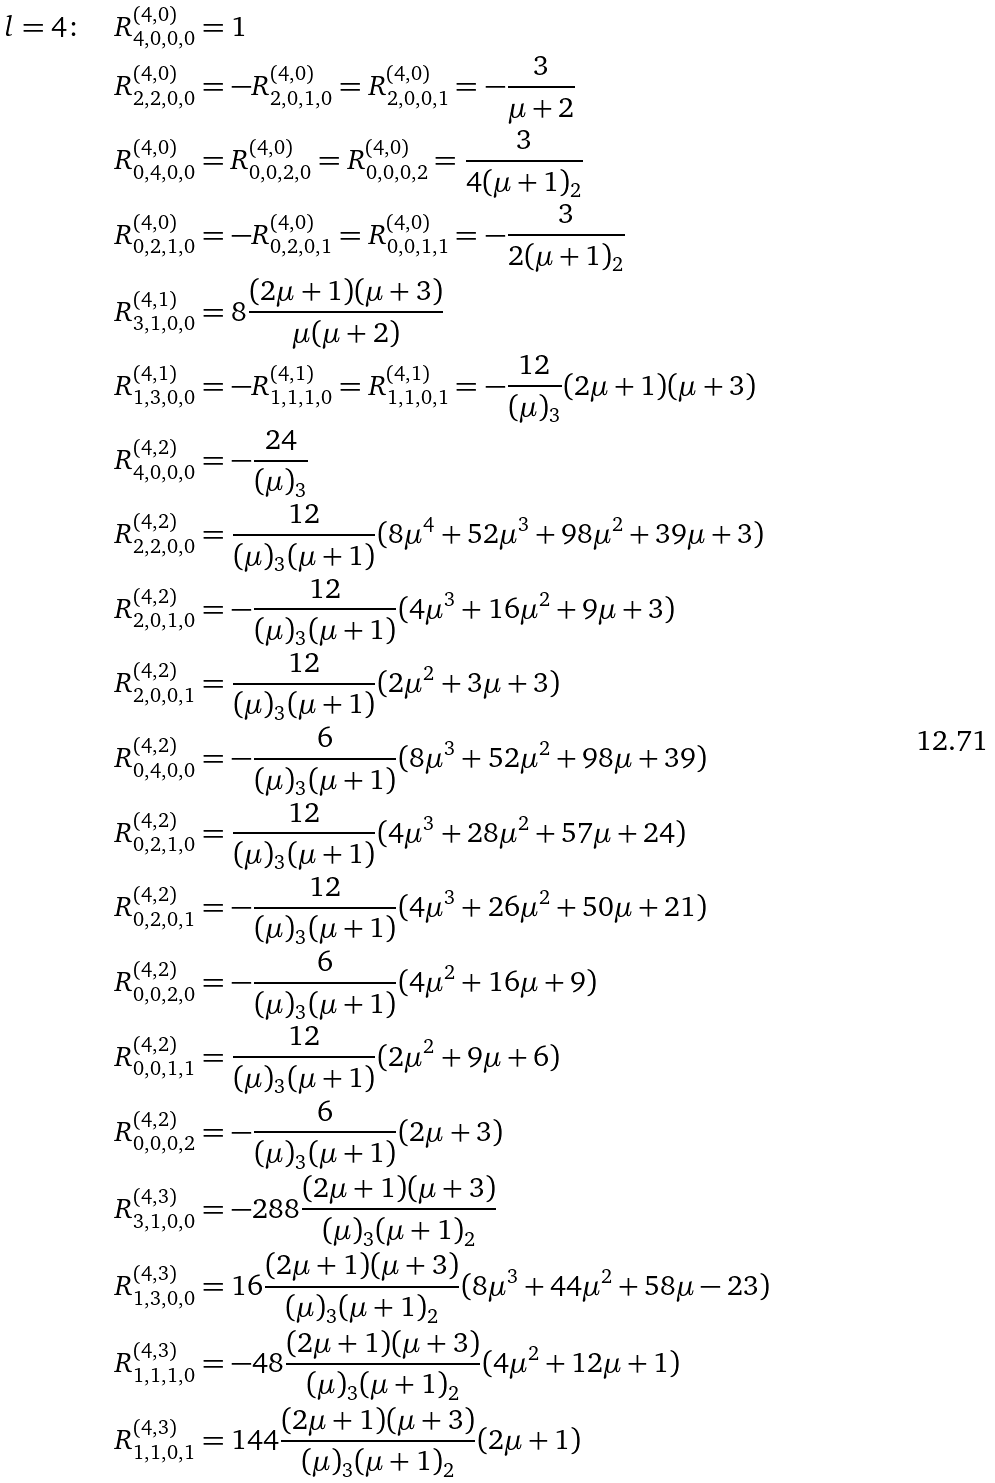<formula> <loc_0><loc_0><loc_500><loc_500>l = 4 \colon & \quad R _ { 4 , 0 , 0 , 0 } ^ { ( 4 , 0 ) } = 1 \\ & \quad R _ { 2 , 2 , 0 , 0 } ^ { ( 4 , 0 ) } = - R _ { 2 , 0 , 1 , 0 } ^ { ( 4 , 0 ) } = R _ { 2 , 0 , 0 , 1 } ^ { ( 4 , 0 ) } = - \frac { 3 } { \mu + 2 } \\ & \quad R _ { 0 , 4 , 0 , 0 } ^ { ( 4 , 0 ) } = R _ { 0 , 0 , 2 , 0 } ^ { ( 4 , 0 ) } = R _ { 0 , 0 , 0 , 2 } ^ { ( 4 , 0 ) } = \frac { 3 } { 4 ( \mu + 1 ) _ { 2 } } \\ & \quad R _ { 0 , 2 , 1 , 0 } ^ { ( 4 , 0 ) } = - R _ { 0 , 2 , 0 , 1 } ^ { ( 4 , 0 ) } = R _ { 0 , 0 , 1 , 1 } ^ { ( 4 , 0 ) } = - \frac { 3 } { 2 ( \mu + 1 ) _ { 2 } } \\ & \quad R _ { 3 , 1 , 0 , 0 } ^ { ( 4 , 1 ) } = 8 \frac { ( 2 \mu + 1 ) ( \mu + 3 ) } { \mu ( \mu + 2 ) } \\ & \quad R _ { 1 , 3 , 0 , 0 } ^ { ( 4 , 1 ) } = - R _ { 1 , 1 , 1 , 0 } ^ { ( 4 , 1 ) } = R _ { 1 , 1 , 0 , 1 } ^ { ( 4 , 1 ) } = - \frac { 1 2 } { ( \mu ) _ { 3 } } ( 2 \mu + 1 ) ( \mu + 3 ) \\ & \quad R _ { 4 , 0 , 0 , 0 } ^ { ( 4 , 2 ) } = - \frac { 2 4 } { ( \mu ) _ { 3 } } \\ & \quad R _ { 2 , 2 , 0 , 0 } ^ { ( 4 , 2 ) } = \frac { 1 2 } { ( \mu ) _ { 3 } ( \mu + 1 ) } ( 8 \mu ^ { 4 } + 5 2 \mu ^ { 3 } + 9 8 \mu ^ { 2 } + 3 9 \mu + 3 ) \\ & \quad R _ { 2 , 0 , 1 , 0 } ^ { ( 4 , 2 ) } = - \frac { 1 2 } { ( \mu ) _ { 3 } ( \mu + 1 ) } ( 4 \mu ^ { 3 } + 1 6 \mu ^ { 2 } + 9 \mu + 3 ) \\ & \quad R _ { 2 , 0 , 0 , 1 } ^ { ( 4 , 2 ) } = \frac { 1 2 } { ( \mu ) _ { 3 } ( \mu + 1 ) } ( 2 \mu ^ { 2 } + 3 \mu + 3 ) \\ & \quad R _ { 0 , 4 , 0 , 0 } ^ { ( 4 , 2 ) } = - \frac { 6 } { ( \mu ) _ { 3 } ( \mu + 1 ) } ( 8 \mu ^ { 3 } + 5 2 \mu ^ { 2 } + 9 8 \mu + 3 9 ) \\ & \quad R _ { 0 , 2 , 1 , 0 } ^ { ( 4 , 2 ) } = \frac { 1 2 } { ( \mu ) _ { 3 } ( \mu + 1 ) } ( 4 \mu ^ { 3 } + 2 8 \mu ^ { 2 } + 5 7 \mu + 2 4 ) \\ & \quad R _ { 0 , 2 , 0 , 1 } ^ { ( 4 , 2 ) } = - \frac { 1 2 } { ( \mu ) _ { 3 } ( \mu + 1 ) } ( 4 \mu ^ { 3 } + 2 6 \mu ^ { 2 } + 5 0 \mu + 2 1 ) \\ & \quad R _ { 0 , 0 , 2 , 0 } ^ { ( 4 , 2 ) } = - \frac { 6 } { ( \mu ) _ { 3 } ( \mu + 1 ) } ( 4 \mu ^ { 2 } + 1 6 \mu + 9 ) \\ & \quad R _ { 0 , 0 , 1 , 1 } ^ { ( 4 , 2 ) } = \frac { 1 2 } { ( \mu ) _ { 3 } ( \mu + 1 ) } ( 2 \mu ^ { 2 } + 9 \mu + 6 ) \\ & \quad R _ { 0 , 0 , 0 , 2 } ^ { ( 4 , 2 ) } = - \frac { 6 } { ( \mu ) _ { 3 } ( \mu + 1 ) } ( 2 \mu + 3 ) \\ & \quad R _ { 3 , 1 , 0 , 0 } ^ { ( 4 , 3 ) } = - 2 8 8 \frac { ( 2 \mu + 1 ) ( \mu + 3 ) } { ( \mu ) _ { 3 } ( \mu + 1 ) _ { 2 } } \\ & \quad R _ { 1 , 3 , 0 , 0 } ^ { ( 4 , 3 ) } = 1 6 \frac { ( 2 \mu + 1 ) ( \mu + 3 ) } { ( \mu ) _ { 3 } ( \mu + 1 ) _ { 2 } } ( 8 \mu ^ { 3 } + 4 4 \mu ^ { 2 } + 5 8 \mu - 2 3 ) \\ & \quad R _ { 1 , 1 , 1 , 0 } ^ { ( 4 , 3 ) } = - 4 8 \frac { ( 2 \mu + 1 ) ( \mu + 3 ) } { ( \mu ) _ { 3 } ( \mu + 1 ) _ { 2 } } ( 4 \mu ^ { 2 } + 1 2 \mu + 1 ) \\ & \quad R _ { 1 , 1 , 0 , 1 } ^ { ( 4 , 3 ) } = 1 4 4 \frac { ( 2 \mu + 1 ) ( \mu + 3 ) } { ( \mu ) _ { 3 } ( \mu + 1 ) _ { 2 } } ( 2 \mu + 1 )</formula> 